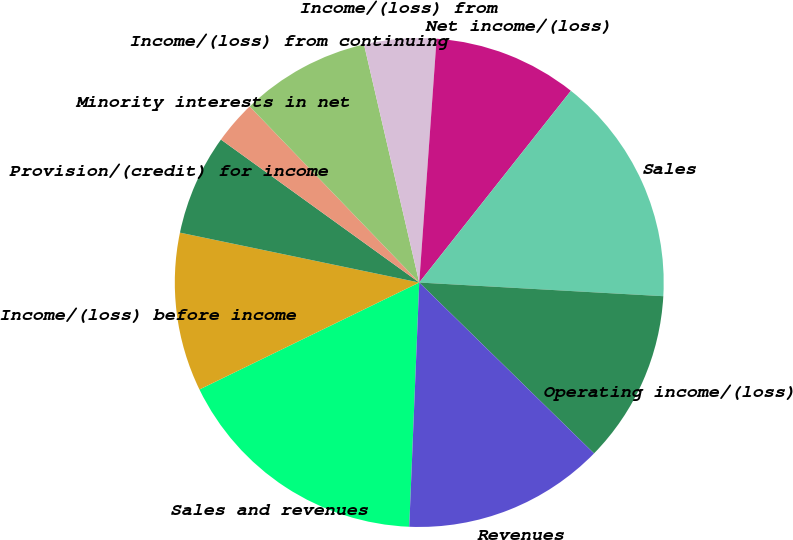<chart> <loc_0><loc_0><loc_500><loc_500><pie_chart><fcel>Sales and revenues<fcel>Income/(loss) before income<fcel>Provision/(credit) for income<fcel>Minority interests in net<fcel>Income/(loss) from continuing<fcel>Income/(loss) from<fcel>Net income/(loss)<fcel>Sales<fcel>Operating income/(loss)<fcel>Revenues<nl><fcel>17.14%<fcel>10.48%<fcel>6.67%<fcel>2.86%<fcel>8.57%<fcel>4.76%<fcel>9.52%<fcel>15.24%<fcel>11.43%<fcel>13.33%<nl></chart> 